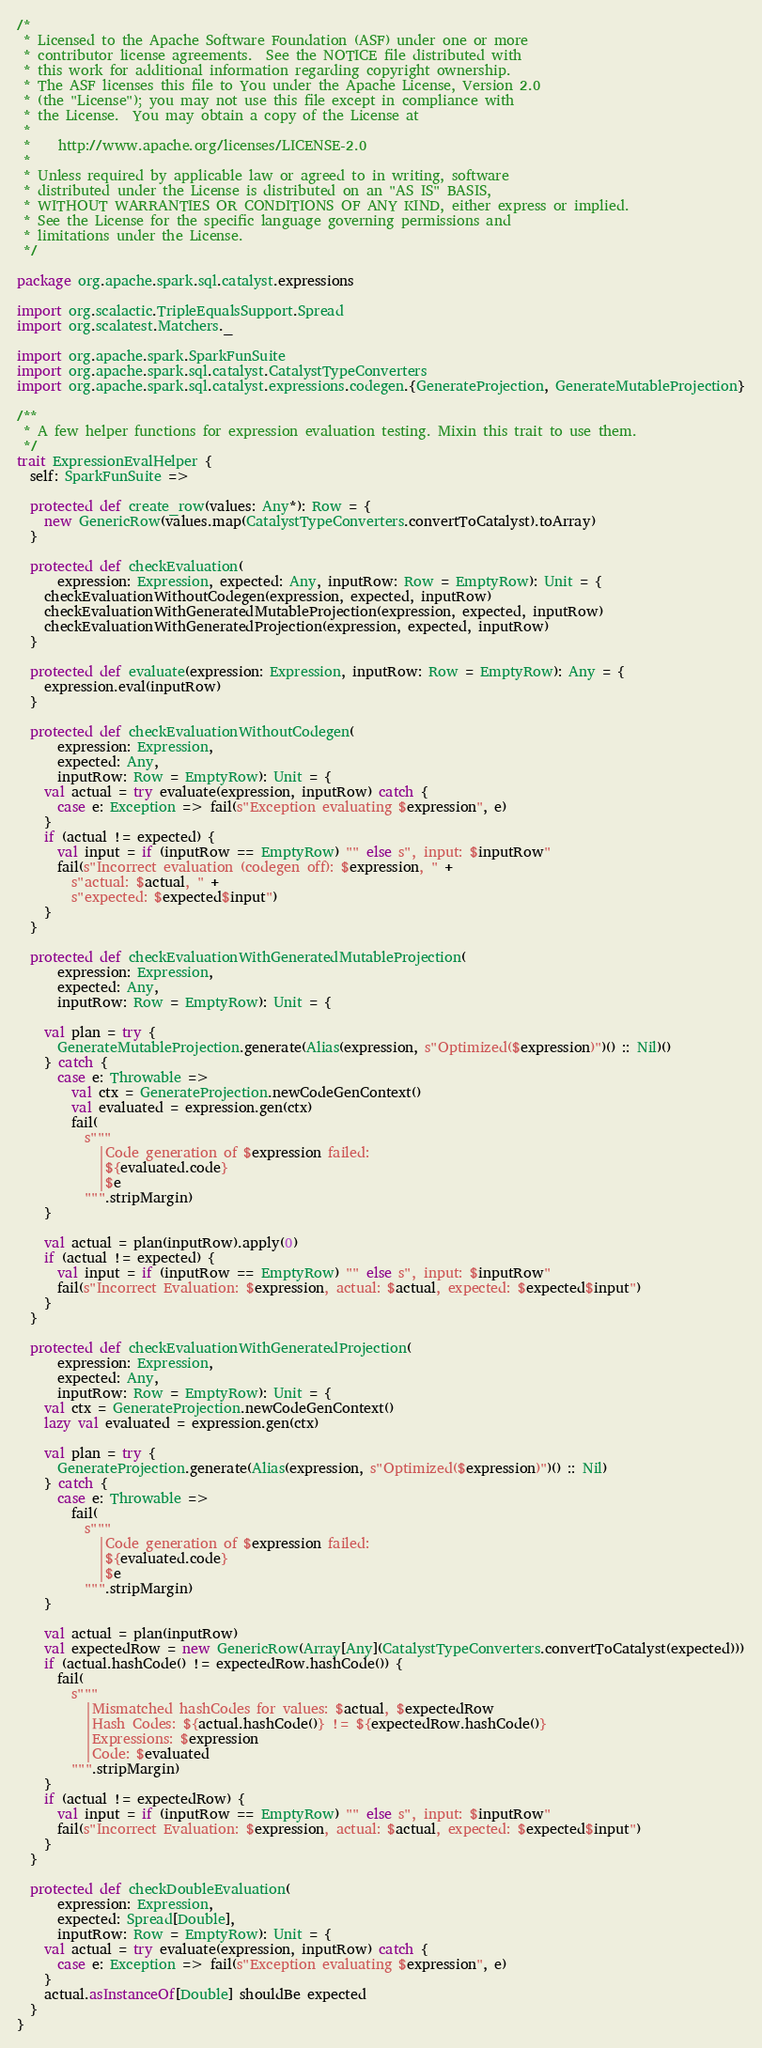Convert code to text. <code><loc_0><loc_0><loc_500><loc_500><_Scala_>/*
 * Licensed to the Apache Software Foundation (ASF) under one or more
 * contributor license agreements.  See the NOTICE file distributed with
 * this work for additional information regarding copyright ownership.
 * The ASF licenses this file to You under the Apache License, Version 2.0
 * (the "License"); you may not use this file except in compliance with
 * the License.  You may obtain a copy of the License at
 *
 *    http://www.apache.org/licenses/LICENSE-2.0
 *
 * Unless required by applicable law or agreed to in writing, software
 * distributed under the License is distributed on an "AS IS" BASIS,
 * WITHOUT WARRANTIES OR CONDITIONS OF ANY KIND, either express or implied.
 * See the License for the specific language governing permissions and
 * limitations under the License.
 */

package org.apache.spark.sql.catalyst.expressions

import org.scalactic.TripleEqualsSupport.Spread
import org.scalatest.Matchers._

import org.apache.spark.SparkFunSuite
import org.apache.spark.sql.catalyst.CatalystTypeConverters
import org.apache.spark.sql.catalyst.expressions.codegen.{GenerateProjection, GenerateMutableProjection}

/**
 * A few helper functions for expression evaluation testing. Mixin this trait to use them.
 */
trait ExpressionEvalHelper {
  self: SparkFunSuite =>

  protected def create_row(values: Any*): Row = {
    new GenericRow(values.map(CatalystTypeConverters.convertToCatalyst).toArray)
  }

  protected def checkEvaluation(
      expression: Expression, expected: Any, inputRow: Row = EmptyRow): Unit = {
    checkEvaluationWithoutCodegen(expression, expected, inputRow)
    checkEvaluationWithGeneratedMutableProjection(expression, expected, inputRow)
    checkEvaluationWithGeneratedProjection(expression, expected, inputRow)
  }

  protected def evaluate(expression: Expression, inputRow: Row = EmptyRow): Any = {
    expression.eval(inputRow)
  }

  protected def checkEvaluationWithoutCodegen(
      expression: Expression,
      expected: Any,
      inputRow: Row = EmptyRow): Unit = {
    val actual = try evaluate(expression, inputRow) catch {
      case e: Exception => fail(s"Exception evaluating $expression", e)
    }
    if (actual != expected) {
      val input = if (inputRow == EmptyRow) "" else s", input: $inputRow"
      fail(s"Incorrect evaluation (codegen off): $expression, " +
        s"actual: $actual, " +
        s"expected: $expected$input")
    }
  }

  protected def checkEvaluationWithGeneratedMutableProjection(
      expression: Expression,
      expected: Any,
      inputRow: Row = EmptyRow): Unit = {

    val plan = try {
      GenerateMutableProjection.generate(Alias(expression, s"Optimized($expression)")() :: Nil)()
    } catch {
      case e: Throwable =>
        val ctx = GenerateProjection.newCodeGenContext()
        val evaluated = expression.gen(ctx)
        fail(
          s"""
            |Code generation of $expression failed:
            |${evaluated.code}
            |$e
          """.stripMargin)
    }

    val actual = plan(inputRow).apply(0)
    if (actual != expected) {
      val input = if (inputRow == EmptyRow) "" else s", input: $inputRow"
      fail(s"Incorrect Evaluation: $expression, actual: $actual, expected: $expected$input")
    }
  }

  protected def checkEvaluationWithGeneratedProjection(
      expression: Expression,
      expected: Any,
      inputRow: Row = EmptyRow): Unit = {
    val ctx = GenerateProjection.newCodeGenContext()
    lazy val evaluated = expression.gen(ctx)

    val plan = try {
      GenerateProjection.generate(Alias(expression, s"Optimized($expression)")() :: Nil)
    } catch {
      case e: Throwable =>
        fail(
          s"""
            |Code generation of $expression failed:
            |${evaluated.code}
            |$e
          """.stripMargin)
    }

    val actual = plan(inputRow)
    val expectedRow = new GenericRow(Array[Any](CatalystTypeConverters.convertToCatalyst(expected)))
    if (actual.hashCode() != expectedRow.hashCode()) {
      fail(
        s"""
          |Mismatched hashCodes for values: $actual, $expectedRow
          |Hash Codes: ${actual.hashCode()} != ${expectedRow.hashCode()}
          |Expressions: $expression
          |Code: $evaluated
        """.stripMargin)
    }
    if (actual != expectedRow) {
      val input = if (inputRow == EmptyRow) "" else s", input: $inputRow"
      fail(s"Incorrect Evaluation: $expression, actual: $actual, expected: $expected$input")
    }
  }

  protected def checkDoubleEvaluation(
      expression: Expression,
      expected: Spread[Double],
      inputRow: Row = EmptyRow): Unit = {
    val actual = try evaluate(expression, inputRow) catch {
      case e: Exception => fail(s"Exception evaluating $expression", e)
    }
    actual.asInstanceOf[Double] shouldBe expected
  }
}
</code> 